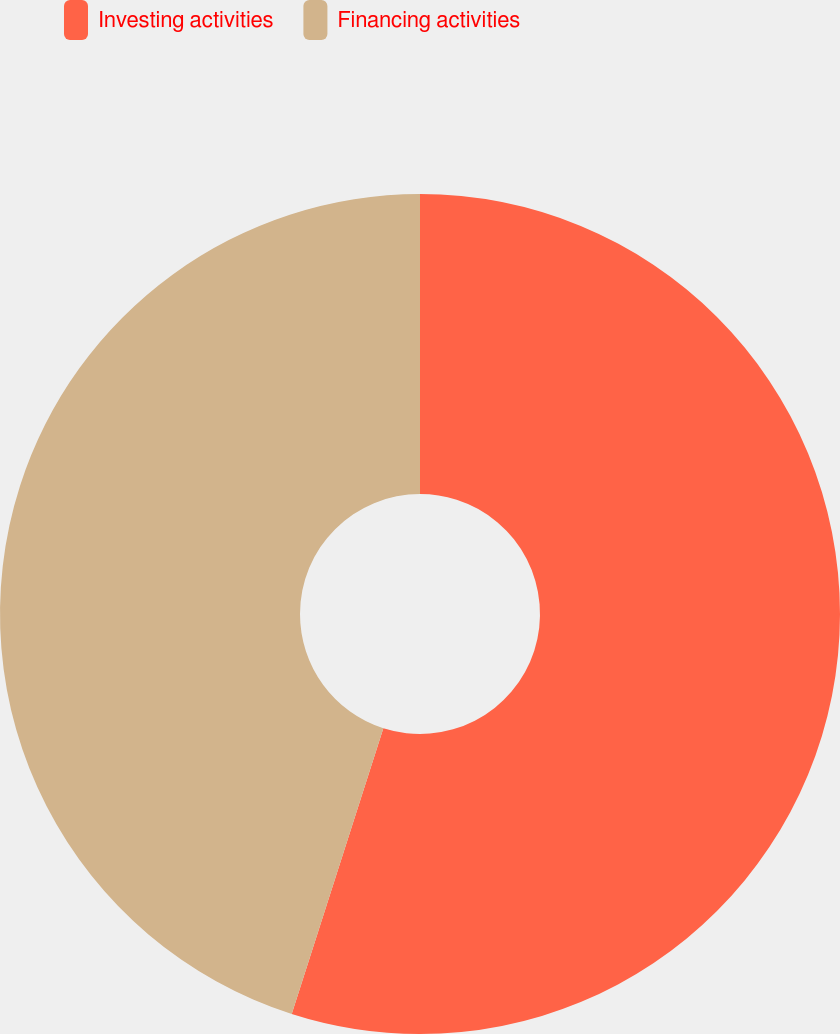Convert chart to OTSL. <chart><loc_0><loc_0><loc_500><loc_500><pie_chart><fcel>Investing activities<fcel>Financing activities<nl><fcel>54.94%<fcel>45.06%<nl></chart> 